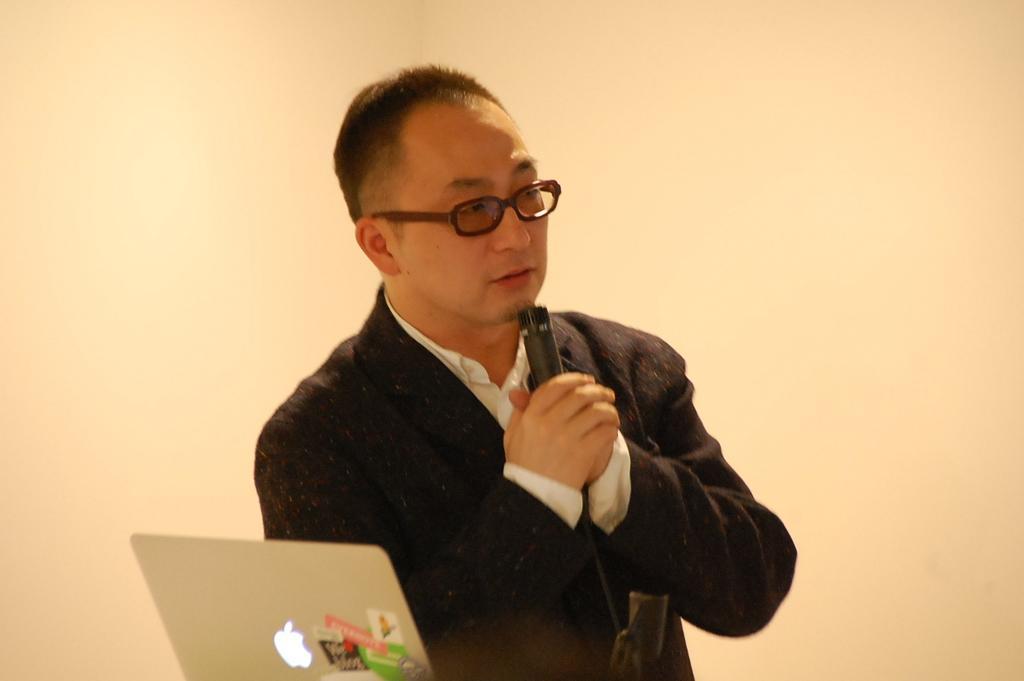Can you describe this image briefly? In this image there is a person holding mike and there is laptop in the foreground. And there is a wall in the background. 